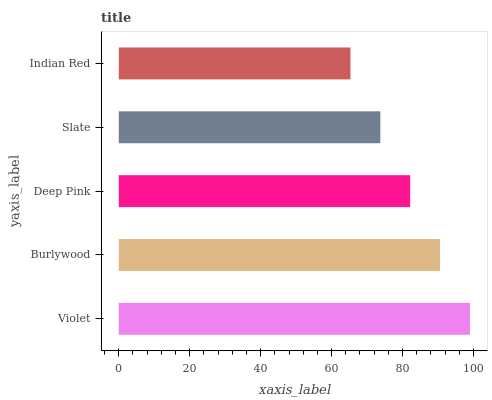Is Indian Red the minimum?
Answer yes or no. Yes. Is Violet the maximum?
Answer yes or no. Yes. Is Burlywood the minimum?
Answer yes or no. No. Is Burlywood the maximum?
Answer yes or no. No. Is Violet greater than Burlywood?
Answer yes or no. Yes. Is Burlywood less than Violet?
Answer yes or no. Yes. Is Burlywood greater than Violet?
Answer yes or no. No. Is Violet less than Burlywood?
Answer yes or no. No. Is Deep Pink the high median?
Answer yes or no. Yes. Is Deep Pink the low median?
Answer yes or no. Yes. Is Indian Red the high median?
Answer yes or no. No. Is Burlywood the low median?
Answer yes or no. No. 